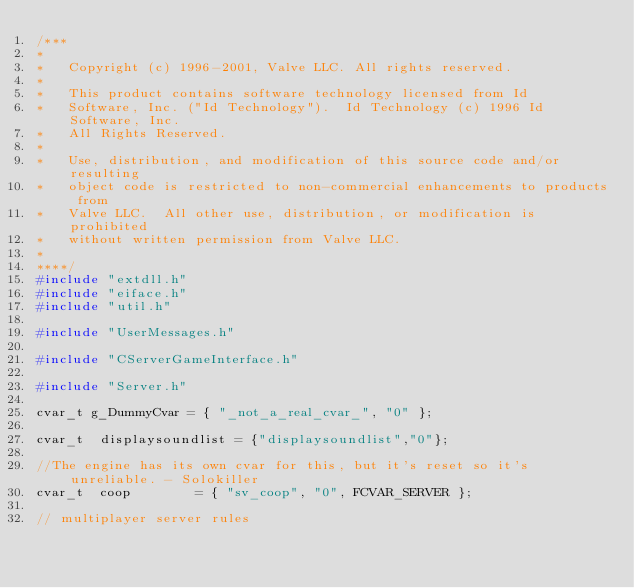<code> <loc_0><loc_0><loc_500><loc_500><_C++_>/***
*
*	Copyright (c) 1996-2001, Valve LLC. All rights reserved.
*	
*	This product contains software technology licensed from Id 
*	Software, Inc. ("Id Technology").  Id Technology (c) 1996 Id Software, Inc. 
*	All Rights Reserved.
*
*   Use, distribution, and modification of this source code and/or resulting
*   object code is restricted to non-commercial enhancements to products from
*   Valve LLC.  All other use, distribution, or modification is prohibited
*   without written permission from Valve LLC.
*
****/
#include "extdll.h"
#include "eiface.h"
#include "util.h"

#include "UserMessages.h"

#include "CServerGameInterface.h"

#include "Server.h"

cvar_t g_DummyCvar = { "_not_a_real_cvar_", "0" };

cvar_t	displaysoundlist = {"displaysoundlist","0"};

//The engine has its own cvar for this, but it's reset so it's unreliable. - Solokiller
cvar_t	coop		= { "sv_coop", "0", FCVAR_SERVER };

// multiplayer server rules</code> 